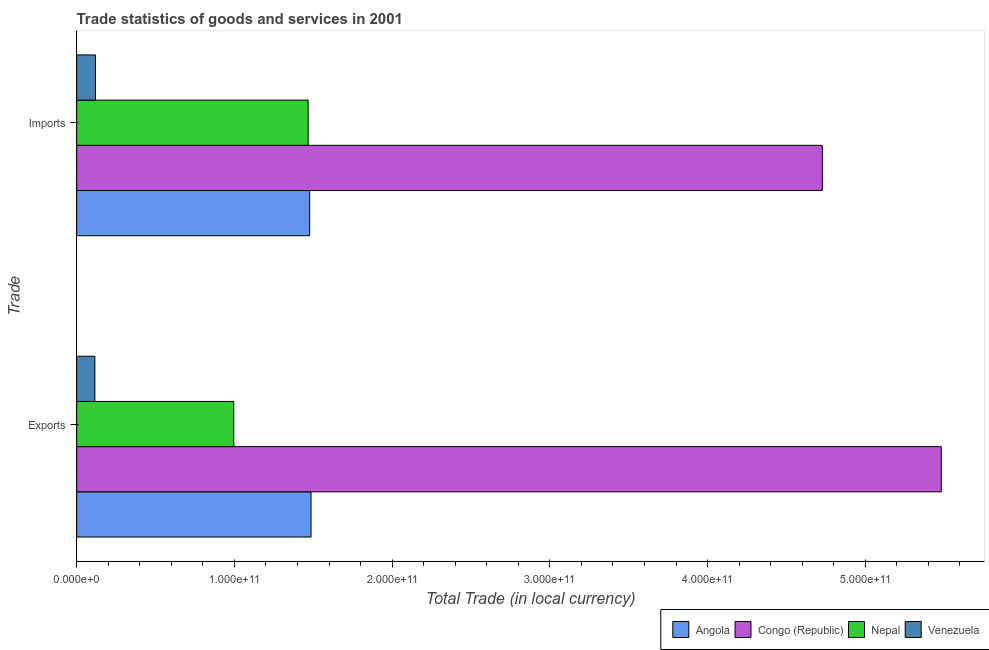How many groups of bars are there?
Your answer should be compact. 2. Are the number of bars per tick equal to the number of legend labels?
Offer a very short reply. Yes. What is the label of the 2nd group of bars from the top?
Your answer should be compact. Exports. What is the imports of goods and services in Venezuela?
Make the answer very short. 1.19e+1. Across all countries, what is the maximum imports of goods and services?
Your answer should be very brief. 4.73e+11. Across all countries, what is the minimum imports of goods and services?
Your answer should be very brief. 1.19e+1. In which country was the export of goods and services maximum?
Make the answer very short. Congo (Republic). In which country was the imports of goods and services minimum?
Your answer should be compact. Venezuela. What is the total export of goods and services in the graph?
Provide a succinct answer. 8.08e+11. What is the difference between the export of goods and services in Nepal and that in Angola?
Your answer should be compact. -4.90e+1. What is the difference between the export of goods and services in Angola and the imports of goods and services in Congo (Republic)?
Provide a succinct answer. -3.24e+11. What is the average imports of goods and services per country?
Offer a very short reply. 1.95e+11. What is the difference between the export of goods and services and imports of goods and services in Congo (Republic)?
Provide a short and direct response. 7.54e+1. What is the ratio of the imports of goods and services in Congo (Republic) to that in Nepal?
Keep it short and to the point. 3.22. Is the imports of goods and services in Congo (Republic) less than that in Venezuela?
Your answer should be very brief. No. In how many countries, is the export of goods and services greater than the average export of goods and services taken over all countries?
Provide a succinct answer. 1. What does the 4th bar from the top in Imports represents?
Offer a terse response. Angola. What does the 4th bar from the bottom in Exports represents?
Your response must be concise. Venezuela. Are all the bars in the graph horizontal?
Your response must be concise. Yes. What is the difference between two consecutive major ticks on the X-axis?
Offer a terse response. 1.00e+11. Are the values on the major ticks of X-axis written in scientific E-notation?
Keep it short and to the point. Yes. Does the graph contain grids?
Offer a terse response. No. Where does the legend appear in the graph?
Provide a succinct answer. Bottom right. How are the legend labels stacked?
Your response must be concise. Horizontal. What is the title of the graph?
Provide a short and direct response. Trade statistics of goods and services in 2001. What is the label or title of the X-axis?
Offer a very short reply. Total Trade (in local currency). What is the label or title of the Y-axis?
Your response must be concise. Trade. What is the Total Trade (in local currency) of Angola in Exports?
Your answer should be compact. 1.49e+11. What is the Total Trade (in local currency) of Congo (Republic) in Exports?
Your answer should be very brief. 5.48e+11. What is the Total Trade (in local currency) in Nepal in Exports?
Provide a short and direct response. 9.96e+1. What is the Total Trade (in local currency) in Venezuela in Exports?
Your response must be concise. 1.15e+1. What is the Total Trade (in local currency) of Angola in Imports?
Keep it short and to the point. 1.48e+11. What is the Total Trade (in local currency) of Congo (Republic) in Imports?
Give a very brief answer. 4.73e+11. What is the Total Trade (in local currency) in Nepal in Imports?
Give a very brief answer. 1.47e+11. What is the Total Trade (in local currency) in Venezuela in Imports?
Make the answer very short. 1.19e+1. Across all Trade, what is the maximum Total Trade (in local currency) in Angola?
Your response must be concise. 1.49e+11. Across all Trade, what is the maximum Total Trade (in local currency) in Congo (Republic)?
Your answer should be very brief. 5.48e+11. Across all Trade, what is the maximum Total Trade (in local currency) of Nepal?
Keep it short and to the point. 1.47e+11. Across all Trade, what is the maximum Total Trade (in local currency) in Venezuela?
Your answer should be very brief. 1.19e+1. Across all Trade, what is the minimum Total Trade (in local currency) in Angola?
Your answer should be compact. 1.48e+11. Across all Trade, what is the minimum Total Trade (in local currency) of Congo (Republic)?
Provide a short and direct response. 4.73e+11. Across all Trade, what is the minimum Total Trade (in local currency) of Nepal?
Provide a short and direct response. 9.96e+1. Across all Trade, what is the minimum Total Trade (in local currency) of Venezuela?
Your response must be concise. 1.15e+1. What is the total Total Trade (in local currency) of Angola in the graph?
Give a very brief answer. 2.96e+11. What is the total Total Trade (in local currency) of Congo (Republic) in the graph?
Provide a short and direct response. 1.02e+12. What is the total Total Trade (in local currency) in Nepal in the graph?
Ensure brevity in your answer.  2.46e+11. What is the total Total Trade (in local currency) in Venezuela in the graph?
Provide a succinct answer. 2.35e+1. What is the difference between the Total Trade (in local currency) in Angola in Exports and that in Imports?
Your answer should be compact. 8.72e+08. What is the difference between the Total Trade (in local currency) in Congo (Republic) in Exports and that in Imports?
Provide a succinct answer. 7.54e+1. What is the difference between the Total Trade (in local currency) of Nepal in Exports and that in Imports?
Offer a very short reply. -4.71e+1. What is the difference between the Total Trade (in local currency) of Venezuela in Exports and that in Imports?
Offer a terse response. -3.88e+08. What is the difference between the Total Trade (in local currency) of Angola in Exports and the Total Trade (in local currency) of Congo (Republic) in Imports?
Keep it short and to the point. -3.24e+11. What is the difference between the Total Trade (in local currency) of Angola in Exports and the Total Trade (in local currency) of Nepal in Imports?
Ensure brevity in your answer.  1.84e+09. What is the difference between the Total Trade (in local currency) in Angola in Exports and the Total Trade (in local currency) in Venezuela in Imports?
Your answer should be very brief. 1.37e+11. What is the difference between the Total Trade (in local currency) of Congo (Republic) in Exports and the Total Trade (in local currency) of Nepal in Imports?
Offer a terse response. 4.01e+11. What is the difference between the Total Trade (in local currency) in Congo (Republic) in Exports and the Total Trade (in local currency) in Venezuela in Imports?
Give a very brief answer. 5.36e+11. What is the difference between the Total Trade (in local currency) of Nepal in Exports and the Total Trade (in local currency) of Venezuela in Imports?
Give a very brief answer. 8.77e+1. What is the average Total Trade (in local currency) of Angola per Trade?
Provide a succinct answer. 1.48e+11. What is the average Total Trade (in local currency) of Congo (Republic) per Trade?
Ensure brevity in your answer.  5.10e+11. What is the average Total Trade (in local currency) in Nepal per Trade?
Keep it short and to the point. 1.23e+11. What is the average Total Trade (in local currency) in Venezuela per Trade?
Your answer should be very brief. 1.17e+1. What is the difference between the Total Trade (in local currency) of Angola and Total Trade (in local currency) of Congo (Republic) in Exports?
Provide a succinct answer. -4.00e+11. What is the difference between the Total Trade (in local currency) of Angola and Total Trade (in local currency) of Nepal in Exports?
Provide a succinct answer. 4.90e+1. What is the difference between the Total Trade (in local currency) of Angola and Total Trade (in local currency) of Venezuela in Exports?
Keep it short and to the point. 1.37e+11. What is the difference between the Total Trade (in local currency) in Congo (Republic) and Total Trade (in local currency) in Nepal in Exports?
Keep it short and to the point. 4.49e+11. What is the difference between the Total Trade (in local currency) in Congo (Republic) and Total Trade (in local currency) in Venezuela in Exports?
Make the answer very short. 5.37e+11. What is the difference between the Total Trade (in local currency) in Nepal and Total Trade (in local currency) in Venezuela in Exports?
Your response must be concise. 8.81e+1. What is the difference between the Total Trade (in local currency) in Angola and Total Trade (in local currency) in Congo (Republic) in Imports?
Offer a terse response. -3.25e+11. What is the difference between the Total Trade (in local currency) in Angola and Total Trade (in local currency) in Nepal in Imports?
Give a very brief answer. 9.70e+08. What is the difference between the Total Trade (in local currency) of Angola and Total Trade (in local currency) of Venezuela in Imports?
Ensure brevity in your answer.  1.36e+11. What is the difference between the Total Trade (in local currency) in Congo (Republic) and Total Trade (in local currency) in Nepal in Imports?
Provide a short and direct response. 3.26e+11. What is the difference between the Total Trade (in local currency) in Congo (Republic) and Total Trade (in local currency) in Venezuela in Imports?
Provide a succinct answer. 4.61e+11. What is the difference between the Total Trade (in local currency) in Nepal and Total Trade (in local currency) in Venezuela in Imports?
Ensure brevity in your answer.  1.35e+11. What is the ratio of the Total Trade (in local currency) in Angola in Exports to that in Imports?
Give a very brief answer. 1.01. What is the ratio of the Total Trade (in local currency) of Congo (Republic) in Exports to that in Imports?
Your answer should be compact. 1.16. What is the ratio of the Total Trade (in local currency) of Nepal in Exports to that in Imports?
Provide a short and direct response. 0.68. What is the ratio of the Total Trade (in local currency) in Venezuela in Exports to that in Imports?
Provide a short and direct response. 0.97. What is the difference between the highest and the second highest Total Trade (in local currency) of Angola?
Keep it short and to the point. 8.72e+08. What is the difference between the highest and the second highest Total Trade (in local currency) of Congo (Republic)?
Your response must be concise. 7.54e+1. What is the difference between the highest and the second highest Total Trade (in local currency) in Nepal?
Your response must be concise. 4.71e+1. What is the difference between the highest and the second highest Total Trade (in local currency) in Venezuela?
Keep it short and to the point. 3.88e+08. What is the difference between the highest and the lowest Total Trade (in local currency) of Angola?
Keep it short and to the point. 8.72e+08. What is the difference between the highest and the lowest Total Trade (in local currency) of Congo (Republic)?
Provide a short and direct response. 7.54e+1. What is the difference between the highest and the lowest Total Trade (in local currency) of Nepal?
Give a very brief answer. 4.71e+1. What is the difference between the highest and the lowest Total Trade (in local currency) of Venezuela?
Keep it short and to the point. 3.88e+08. 